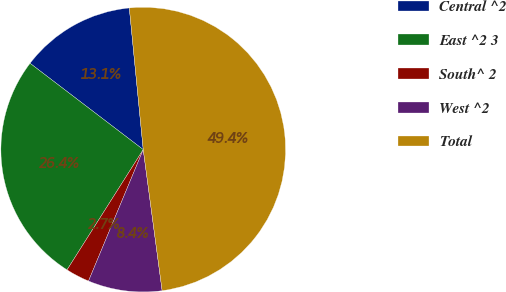Convert chart to OTSL. <chart><loc_0><loc_0><loc_500><loc_500><pie_chart><fcel>Central ^2<fcel>East ^2 3<fcel>South^ 2<fcel>West ^2<fcel>Total<nl><fcel>13.07%<fcel>26.38%<fcel>2.71%<fcel>8.4%<fcel>49.44%<nl></chart> 